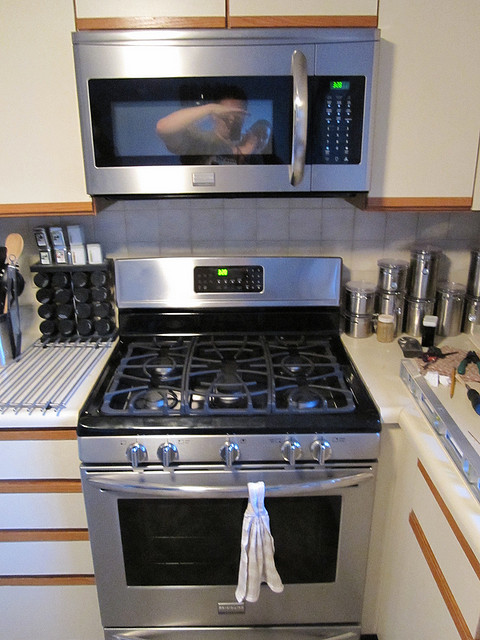Are there any other appliances visible in the picture? Aside from the microwave and stove, there don't appear to be any other appliances visible in this view of the kitchen. 